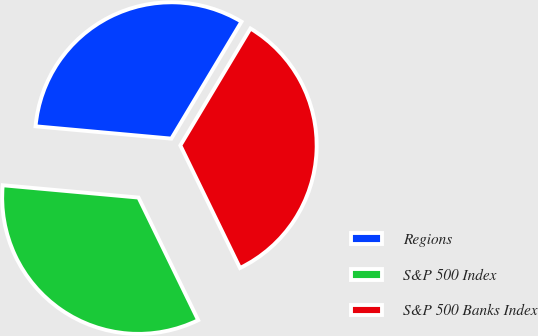Convert chart to OTSL. <chart><loc_0><loc_0><loc_500><loc_500><pie_chart><fcel>Regions<fcel>S&P 500 Index<fcel>S&P 500 Banks Index<nl><fcel>32.16%<fcel>33.65%<fcel>34.19%<nl></chart> 